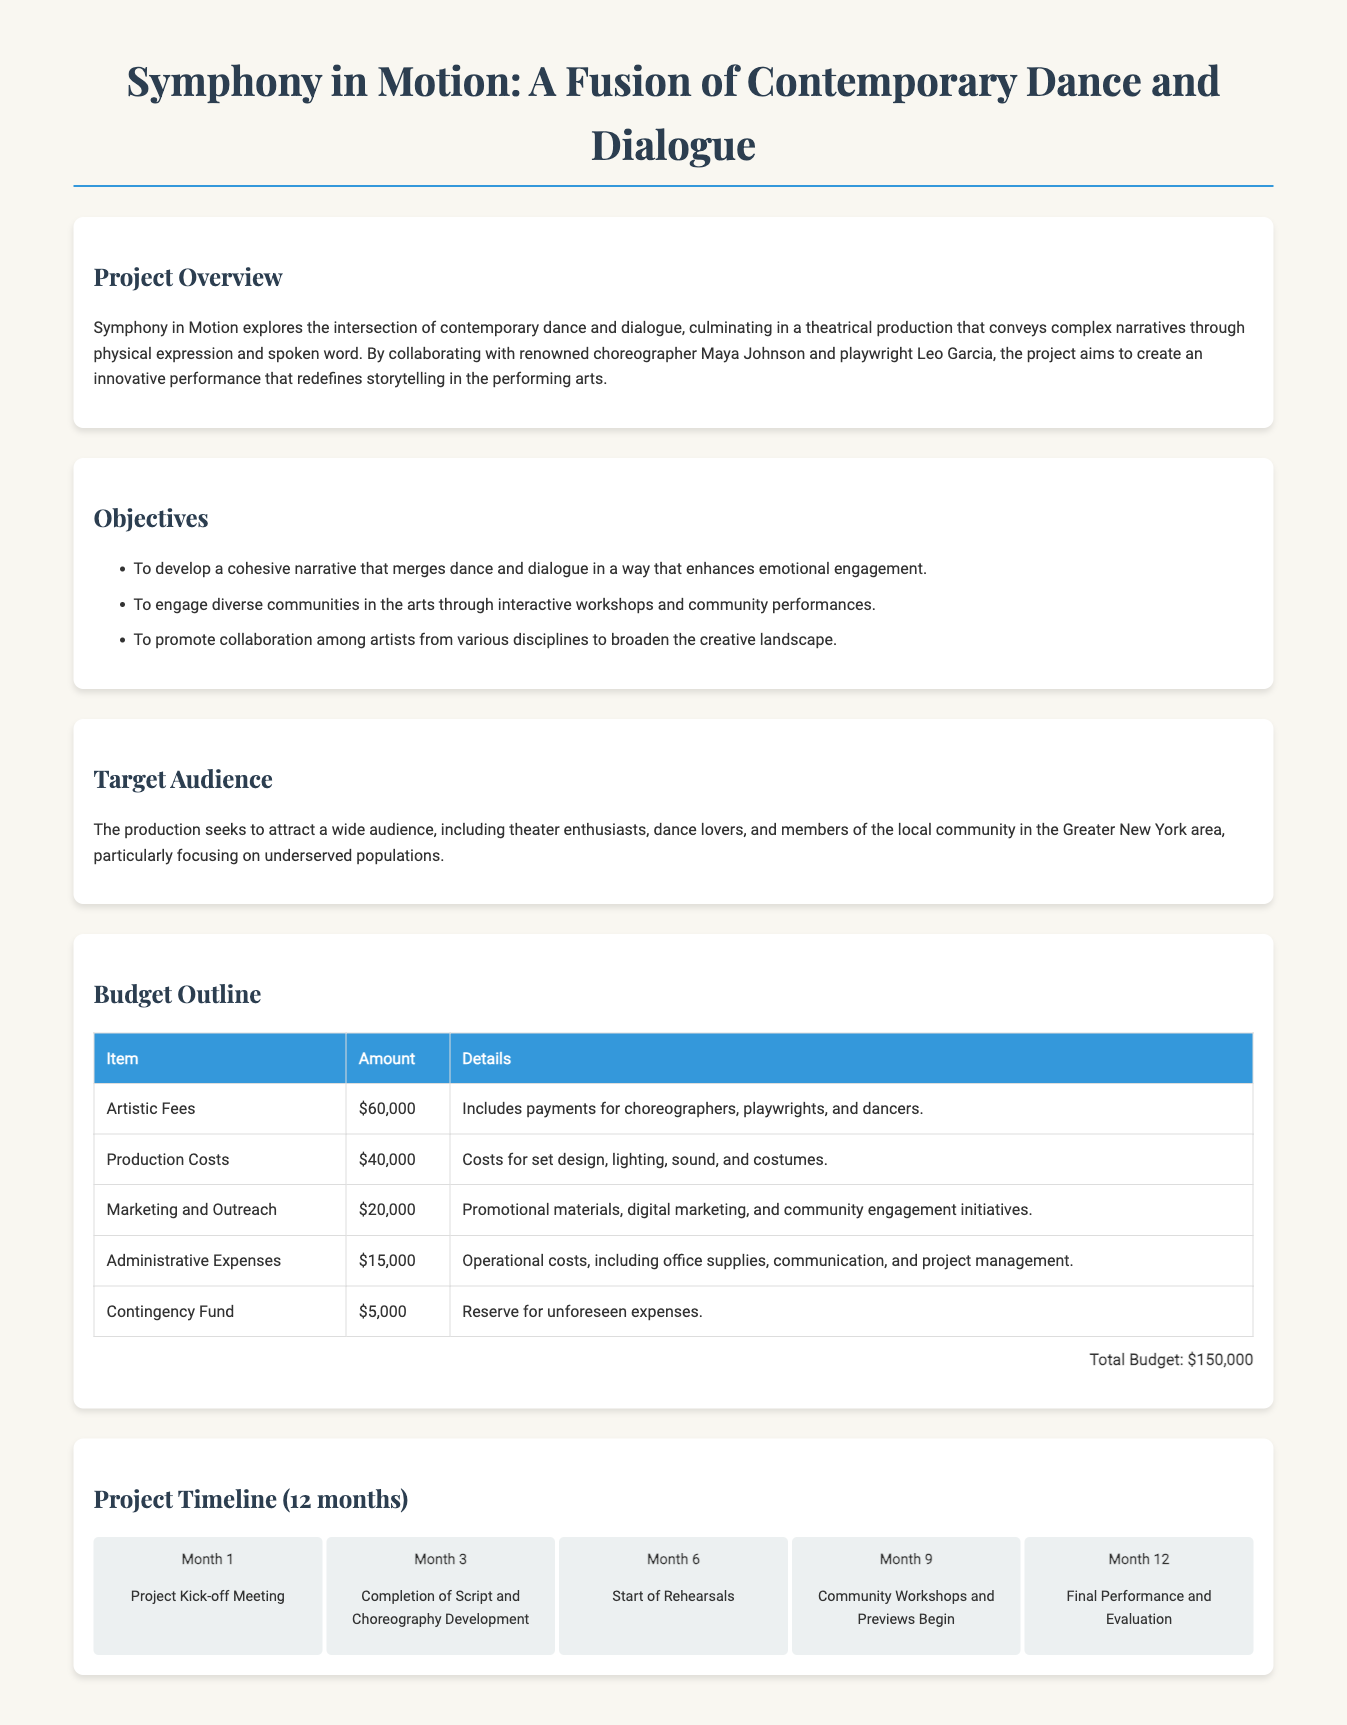What is the title of the grant application? The title of the grant application is prominently displayed at the top of the document.
Answer: Symphony in Motion: A Fusion of Contemporary Dance and Dialogue Who are the key collaborators listed in the project overview? The project overview mentions specific individuals involved in the project.
Answer: Maya Johnson and Leo Garcia What is the total budget for the project? The total budget is calculated from the budget outline provided in the document.
Answer: $150,000 What is the milestone for Month 6? The timeline section lists specific activities associated with each month.
Answer: Start of Rehearsals How much is allocated for Marketing and Outreach? The budget outline includes specific amounts for various expenditure items.
Answer: $20,000 What is one objective of the project? The objectives section lists goals for the project.
Answer: To develop a cohesive narrative that merges dance and dialogue in a way that enhances emotional engagement In which area is the target audience primarily located? The target audience section defines the geographical focus of the project.
Answer: Greater New York area What is the amount set aside for the Contingency Fund? The budget outline includes a specific entry for unforeseen expenses.
Answer: $5,000 When does the project kick-off meeting take place? The timeline provides a specific timeframe for project initiation.
Answer: Month 1 